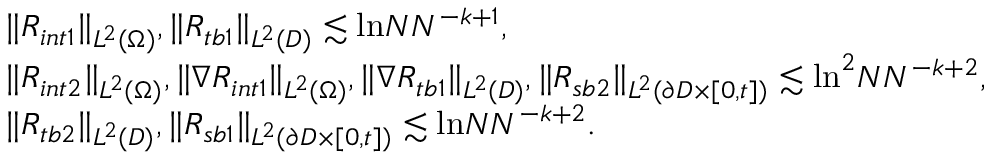Convert formula to latex. <formula><loc_0><loc_0><loc_500><loc_500>\begin{array} { r l } & { \| R _ { i n t 1 } \| _ { L ^ { 2 } ( \Omega ) } , \| R _ { t b 1 } \| _ { L ^ { 2 } ( D ) } \lesssim \ln N N ^ { - k + 1 } , } \\ & { \| R _ { i n t 2 } \| _ { L ^ { 2 } ( \Omega ) } , \| \nabla R _ { i n t 1 } \| _ { L ^ { 2 } ( \Omega ) } , \| \nabla R _ { t b 1 } \| _ { L ^ { 2 } ( D ) } , \| R _ { s b 2 } \| _ { L ^ { 2 } ( \partial D \times [ 0 , t ] ) } \lesssim \ln ^ { 2 } N N ^ { - k + 2 } , } \\ & { \| R _ { t b 2 } \| _ { L ^ { 2 } ( D ) } , \| R _ { s b 1 } \| _ { L ^ { 2 } ( \partial D \times [ 0 , t ] ) } \lesssim \ln N N ^ { - k + 2 } . } \end{array}</formula> 